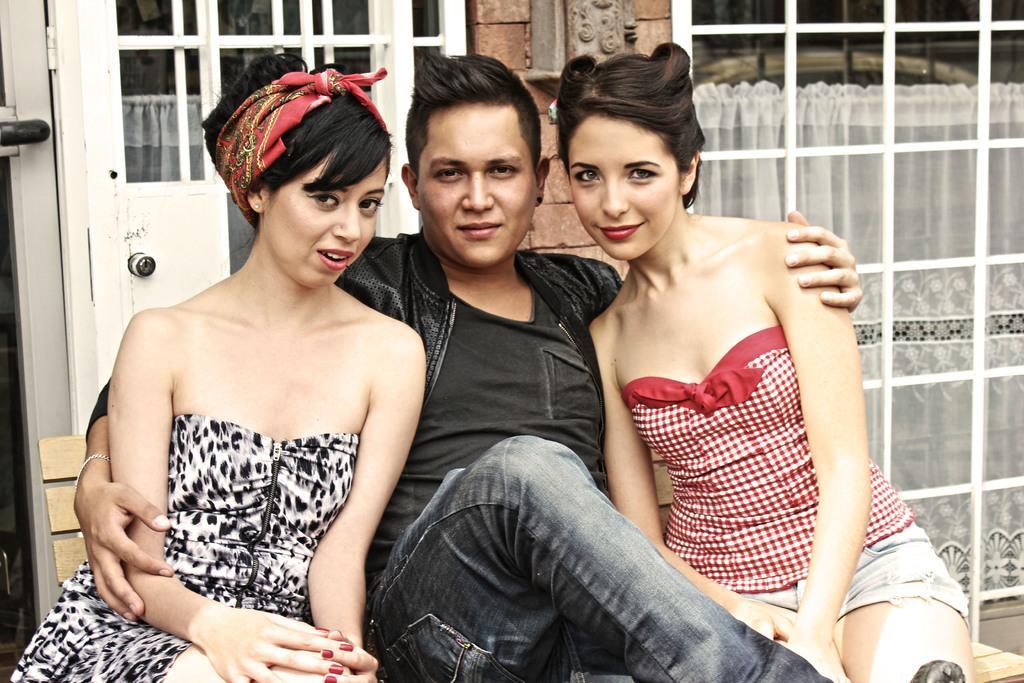How would you summarize this image in a sentence or two? In this image I can see some people. In the background, I can see a white cloth. 